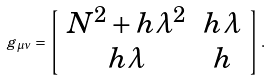Convert formula to latex. <formula><loc_0><loc_0><loc_500><loc_500>g _ { \mu \nu } = \left [ \begin{array} { c c } N ^ { 2 } + h \lambda ^ { 2 } & h \lambda \\ h \lambda & h \end{array} \right ] .</formula> 